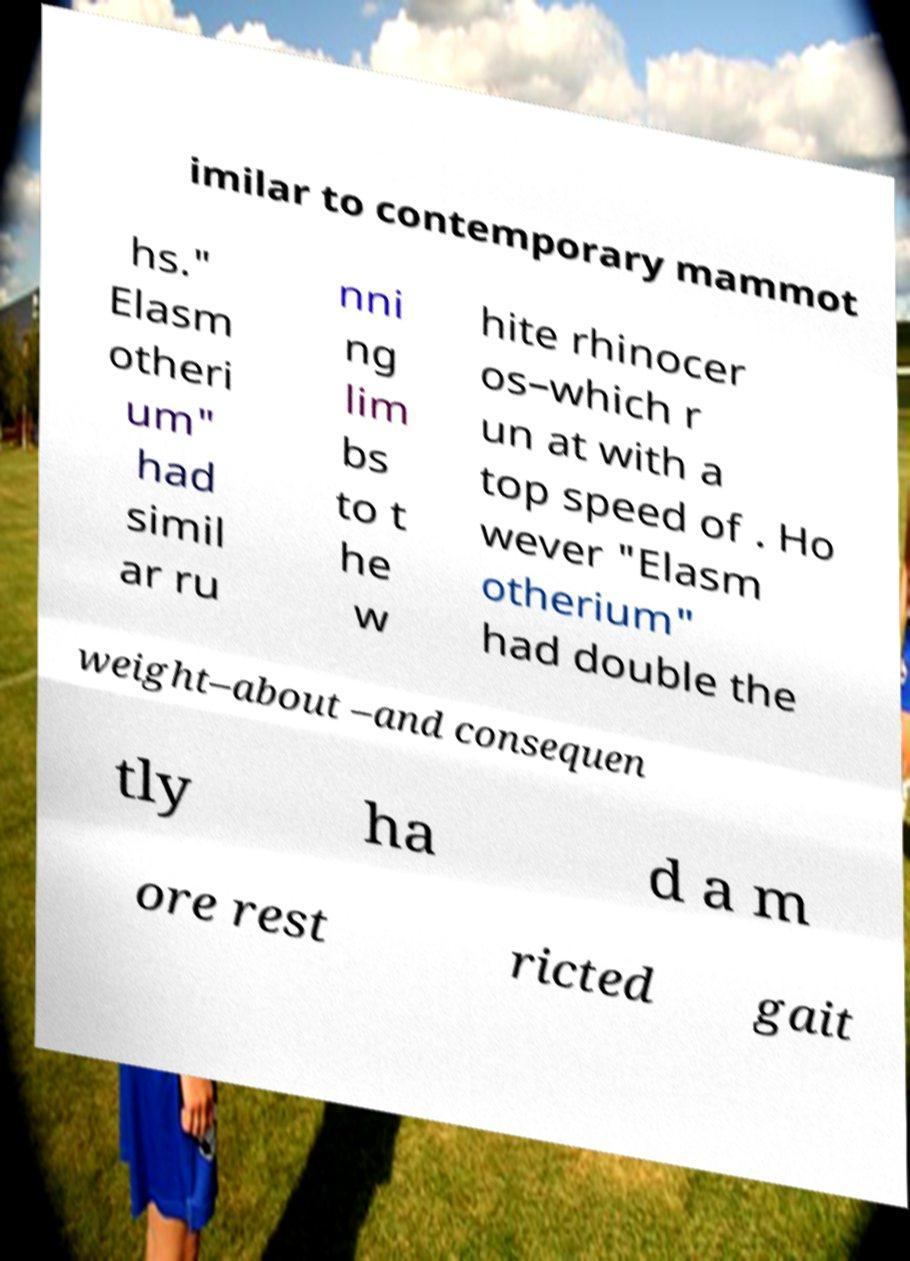Please read and relay the text visible in this image. What does it say? imilar to contemporary mammot hs." Elasm otheri um" had simil ar ru nni ng lim bs to t he w hite rhinocer os–which r un at with a top speed of . Ho wever "Elasm otherium" had double the weight–about –and consequen tly ha d a m ore rest ricted gait 